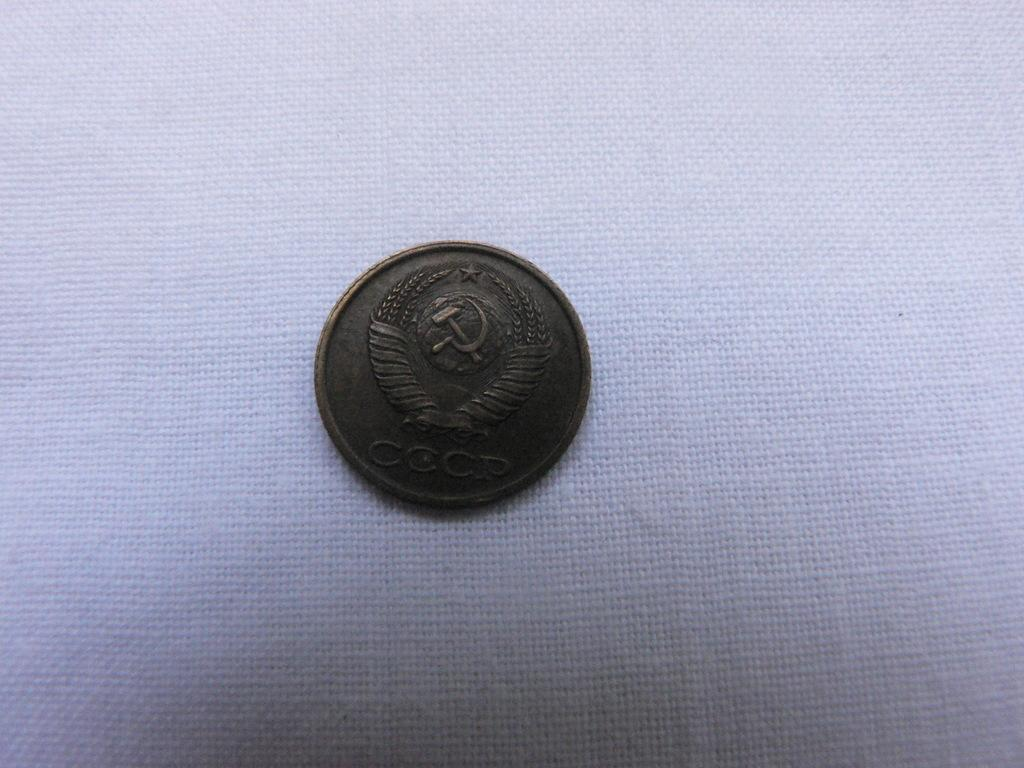<image>
Create a compact narrative representing the image presented. A CCCP coin showcases a hammer and sickle on it. 